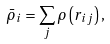<formula> <loc_0><loc_0><loc_500><loc_500>\bar { \rho } _ { i } = \sum _ { j } \rho \left ( r _ { i j } \right ) ,</formula> 